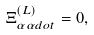Convert formula to latex. <formula><loc_0><loc_0><loc_500><loc_500>\Xi _ { \alpha \alpha d o t } ^ { ( L ) } = 0 ,</formula> 